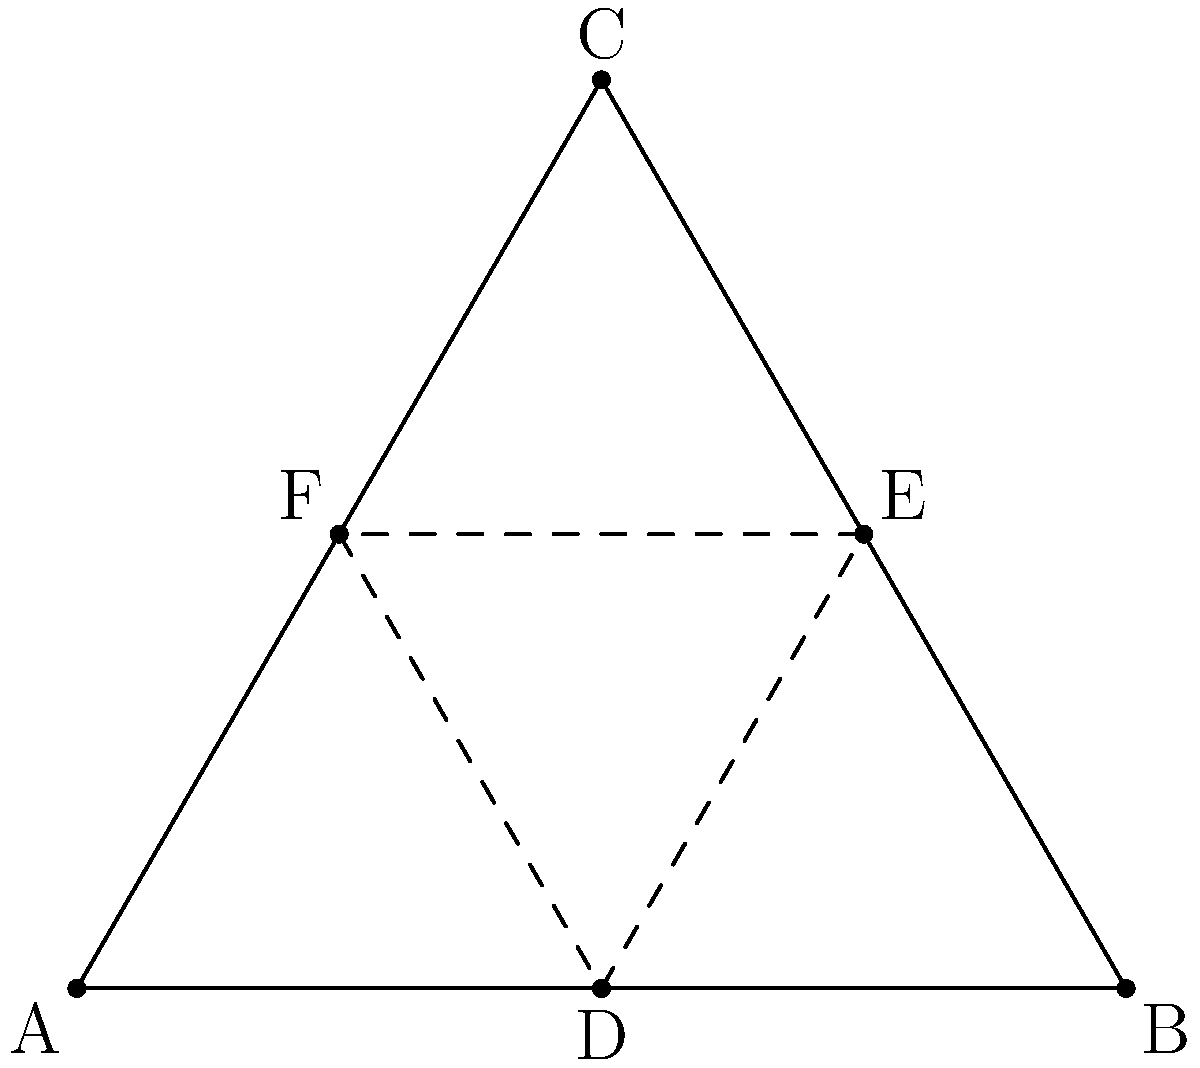In the diagram, triangle ABC represents a group G, and triangle DEF represents a subset H of G. If H forms a coset of a subgroup in G, what is the index of this subgroup in G? Explain your reasoning using the geometric representation and group theory concepts. Let's approach this step-by-step:

1) In group theory, a coset is a translation of a subgroup within the larger group. Geometrically, this is represented by a congruent shape within the larger shape.

2) We can see that triangle DEF is congruent to and contained within triangle ABC. This suggests that H (represented by DEF) is indeed a coset of some subgroup of G (represented by ABC).

3) The index of a subgroup is the number of distinct cosets of that subgroup in the larger group. Geometrically, this would be represented by the number of times the smaller triangle (DEF) can fit into the larger triangle (ABC) without overlap.

4) Looking at the diagram, we can see that triangle DEF takes up exactly 1/3 of the area of triangle ABC. This means that three non-overlapping copies of DEF would exactly cover ABC.

5) In group theory terms, this means that there are three distinct cosets of the subgroup (including the subgroup itself) that together make up the entire group G.

6) The index of a subgroup is defined as $[G:H] = \frac{|G|}{|H|}$, where $|G|$ is the order of the group and $|H|$ is the order of the subgroup. This ratio is equivalent to the number of distinct cosets.

Therefore, the index of the subgroup represented by DEF in the group represented by ABC is 3.
Answer: 3 